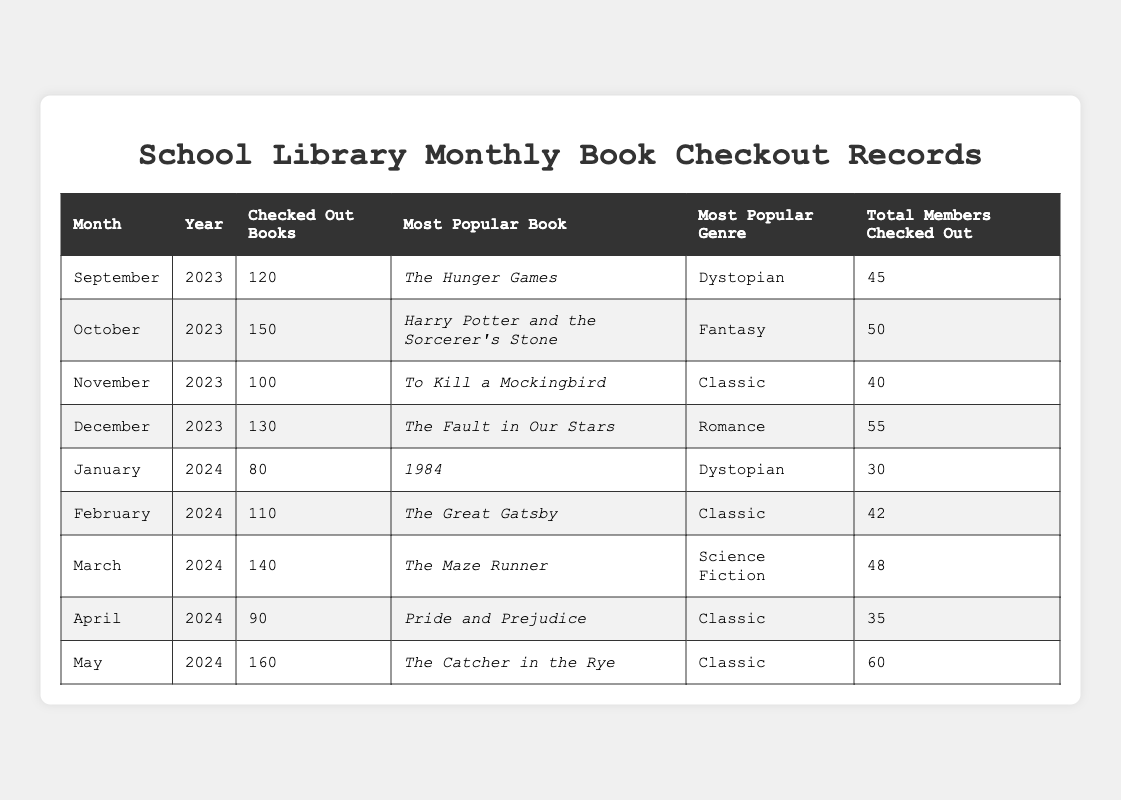What was the most popular book checked out in October 2023? According to the table, the most popular book checked out in October 2023 is "Harry Potter and the Sorcerer's Stone."
Answer: Harry Potter and the Sorcerer's Stone How many total books were checked out in December 2023? The table indicates that a total of 130 books were checked out in December 2023.
Answer: 130 What is the total number of books checked out from September to November 2023? To find the total, we sum the books checked out in September (120), October (150), and November (100). That gives us 120 + 150 + 100 = 370.
Answer: 370 In which month was the least number of books checked out? Reviewing the table, January 2024 had the least number of books checked out at 80.
Answer: January 2024 How many members checked out books in February 2024? In February 2024, a total of 42 members checked out books as stated in the table.
Answer: 42 What is the average number of books checked out per month during the months of September to December 2023? The checked out books from September to December are 120, 150, 100, and 130 respectively. Summing these gives 120 + 150 + 100 + 130 = 500. Dividing by 4 (the number of months) gives us 500 / 4 = 125.
Answer: 125 Which genre was most popular in the month with the highest book checkout? The month with the highest number of book checkouts was May 2024 with 160 books. The most popular genre during this month was "Classic."
Answer: Classic Was "The Fault in Our Stars" more popular than "To Kill a Mockingbird"? In December 2023, "The Fault in Our Stars" was the most popular book, checked out more than "To Kill a Mockingbird," which was the most popular in November. Therefore, it can be said that yes, "The Fault in Our Stars" was more popular than "To Kill a Mockingbird."
Answer: Yes How many books were checked out in total from January to April 2024? Adding the checked out books from January (80), February (110), March (140), and April (90), we get 80 + 110 + 140 + 90 = 420 books.
Answer: 420 What was the most popular genre in March 2024? The most popular genre in March 2024 was "Science Fiction," as shown in the table.
Answer: Science Fiction Was there an increase or decrease in the number of checked out books from October 2023 to November 2023? In October 2023, there were 150 checked out books, and in November 2023, there were 100. This indicates a decrease of 50 books.
Answer: Decrease 